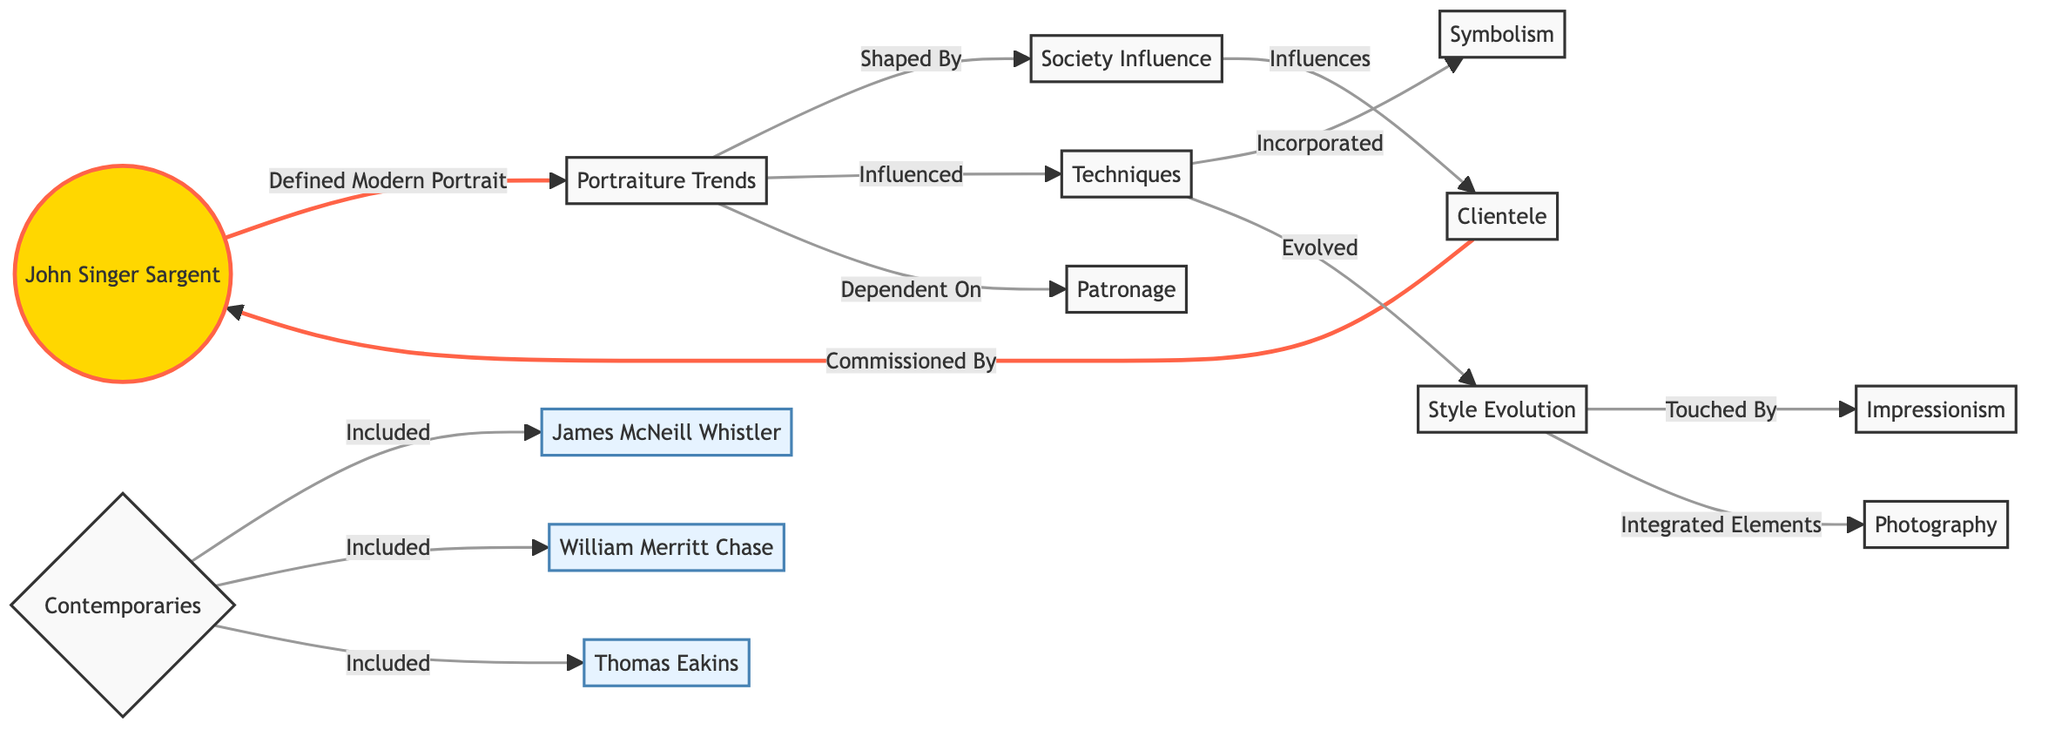What is the primary influence on portraiture trends in the diagram? The primary influence on portraiture trends is society influence, indicated by the directional connection from society influence to portraiture trends.
Answer: society influence How many contemporaries are identified in the diagram? The contemporaries listed in the diagram are James McNeill Whistler, William Merritt Chase, and Thomas Eakins, which totals three.
Answer: three Which technique is specifically incorporated into the evolution of techniques as per this diagram? The diagram indicates that symbolism is specifically incorporated into the evolution of techniques as demonstrated by the direct connection labeled "Incorporated".
Answer: symbolism What evolves from the style evolution node in the diagram? The style evolution node connects to both impressionism and elements of photography, indicating that both aspects evolve from style evolution.
Answer: impressionism, photography Who commissioned John Singer Sargent's work according to the diagram? The diagram shows that clientele commissioned John Singer Sargent's work, as indicated by the connection "Commissioned By".
Answer: clientele What are the techniques influenced by of the portraiture trends? Techniques are influenced by the portraiture trends, as explicitly shown in the flow from portraiture trends to techniques.
Answer: techniques What node comes directly after the patronage node in the diagram? The clientele node comes directly after the patronage node in the diagram, as it shows a dependency relationship where clientele depends on patronage.
Answer: clientele What type of art does the style evolution incorporate based on the diagram? The style evolution incorporates elements of photography, which is highlighted in the flow from style evolution to integrated elements.
Answer: photography Which contemporary artist is specifically highlighted in this diagram? John Singer Sargent is specifically highlighted in the diagram, shown with a distinct color to indicate his significance in comparison to contemporaries.
Answer: John Singer Sargent 